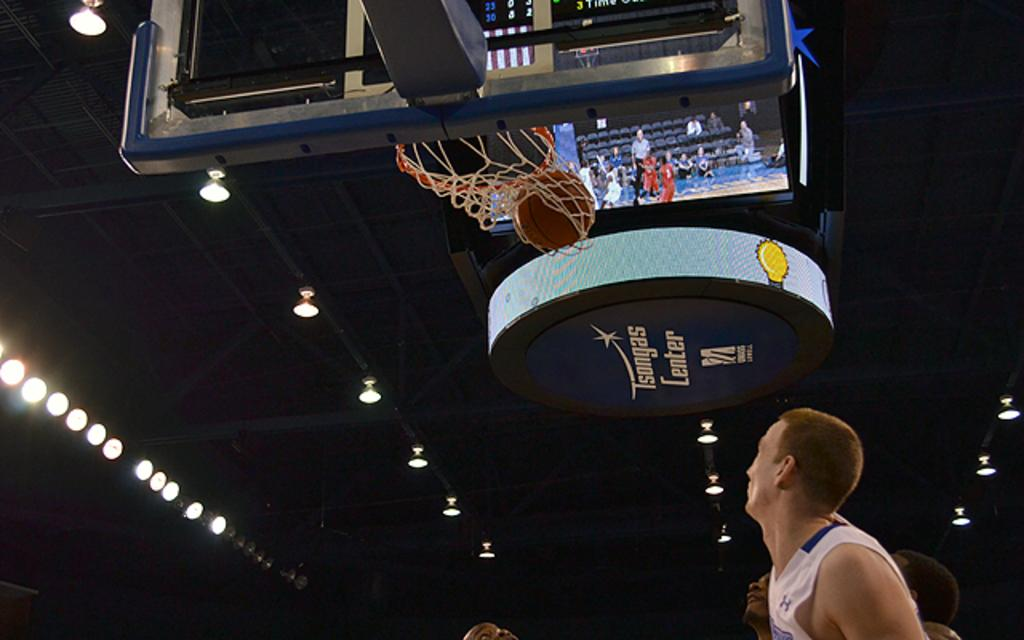<image>
Present a compact description of the photo's key features. a player that is playing basketball under a scoreboard with the word center on it 